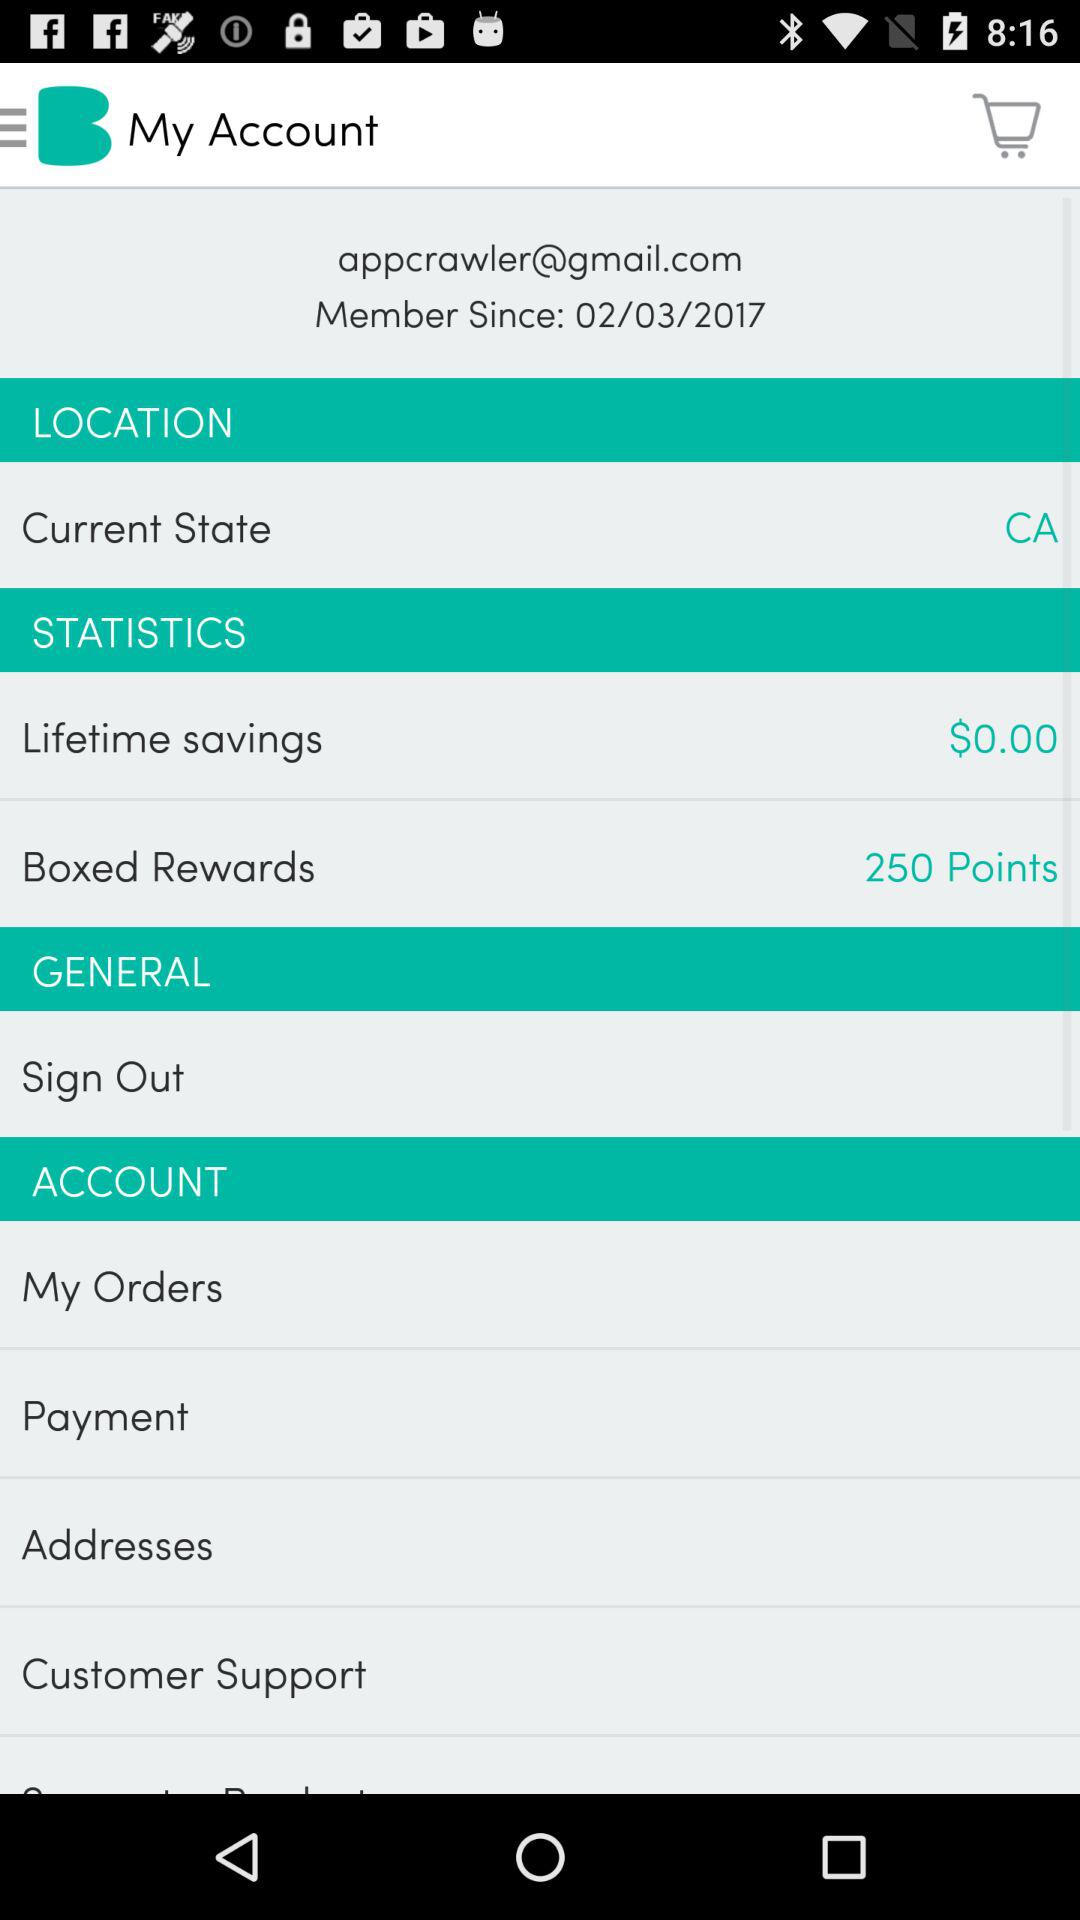Since when is the user a member? The user has been a member since February 3, 2017. 